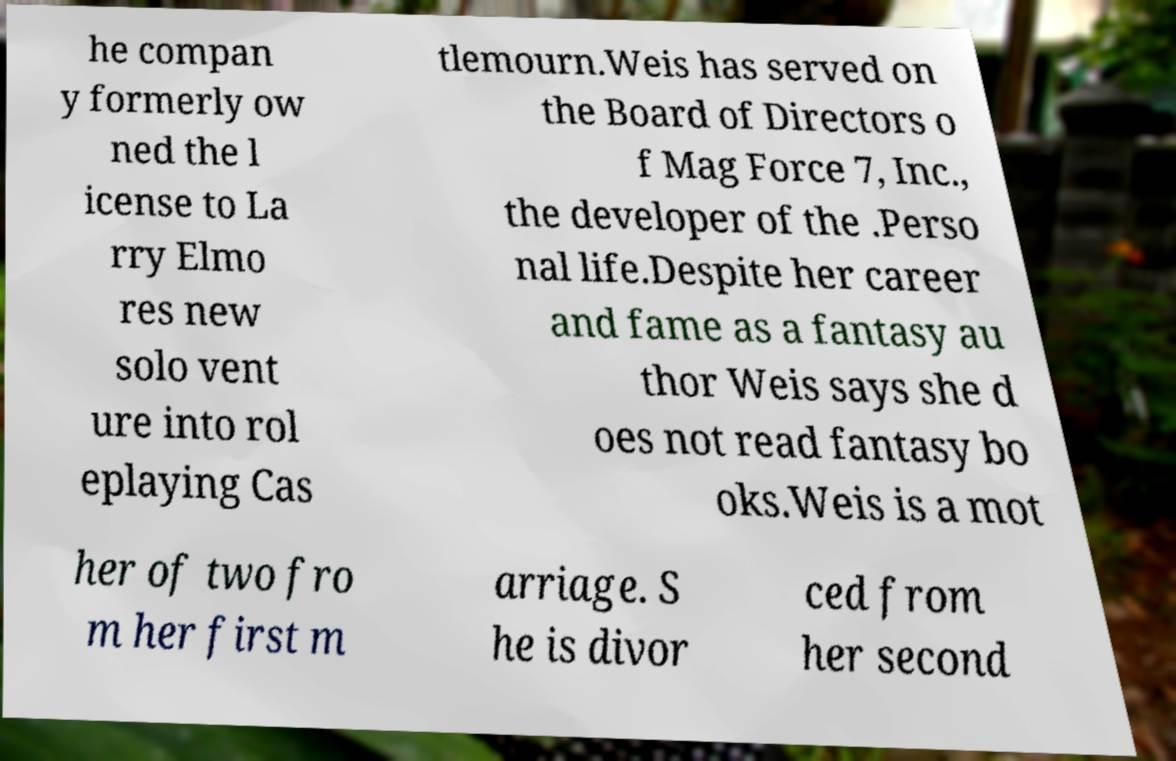Please identify and transcribe the text found in this image. he compan y formerly ow ned the l icense to La rry Elmo res new solo vent ure into rol eplaying Cas tlemourn.Weis has served on the Board of Directors o f Mag Force 7, Inc., the developer of the .Perso nal life.Despite her career and fame as a fantasy au thor Weis says she d oes not read fantasy bo oks.Weis is a mot her of two fro m her first m arriage. S he is divor ced from her second 